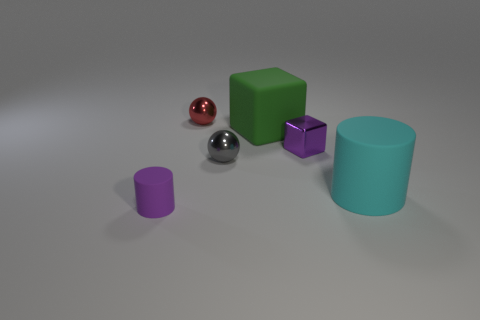Is the shape of the tiny rubber object the same as the big object in front of the green object?
Offer a very short reply. Yes. There is a metal thing that is the same color as the tiny rubber cylinder; what shape is it?
Your response must be concise. Cube. Are there any gray balls made of the same material as the cyan cylinder?
Make the answer very short. No. What is the material of the ball behind the small purple object that is on the right side of the red object?
Offer a terse response. Metal. What size is the rubber cylinder to the right of the big matte block on the right side of the matte cylinder that is in front of the cyan rubber object?
Give a very brief answer. Large. How many other things are the same shape as the large cyan thing?
Offer a very short reply. 1. There is a cylinder to the left of the red ball; is its color the same as the metal cube behind the purple rubber cylinder?
Your response must be concise. Yes. What color is the cube that is the same size as the cyan object?
Give a very brief answer. Green. Are there any small rubber things of the same color as the tiny matte cylinder?
Your response must be concise. No. There is a purple object to the right of the purple cylinder; is it the same size as the large cyan matte cylinder?
Keep it short and to the point. No. 